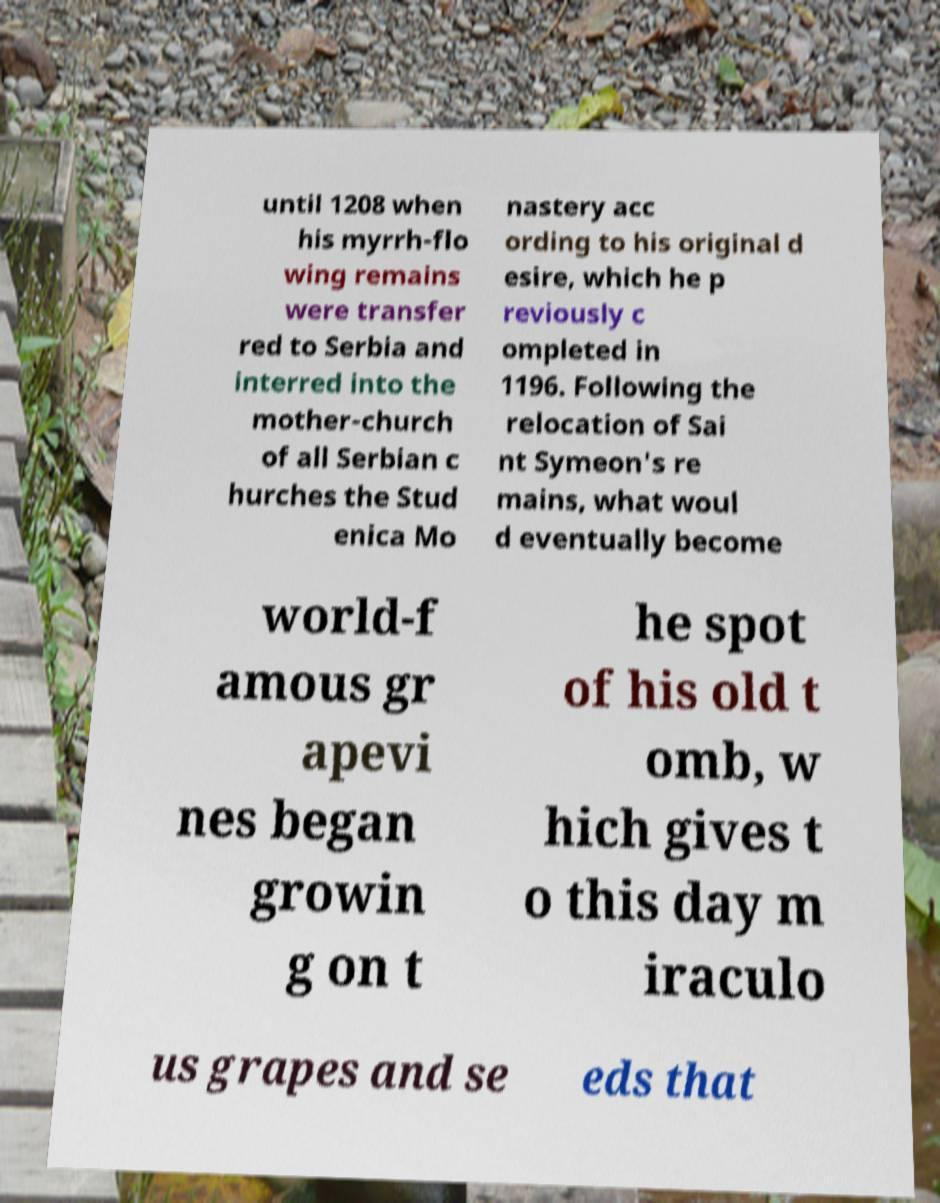What messages or text are displayed in this image? I need them in a readable, typed format. until 1208 when his myrrh-flo wing remains were transfer red to Serbia and interred into the mother-church of all Serbian c hurches the Stud enica Mo nastery acc ording to his original d esire, which he p reviously c ompleted in 1196. Following the relocation of Sai nt Symeon's re mains, what woul d eventually become world-f amous gr apevi nes began growin g on t he spot of his old t omb, w hich gives t o this day m iraculo us grapes and se eds that 